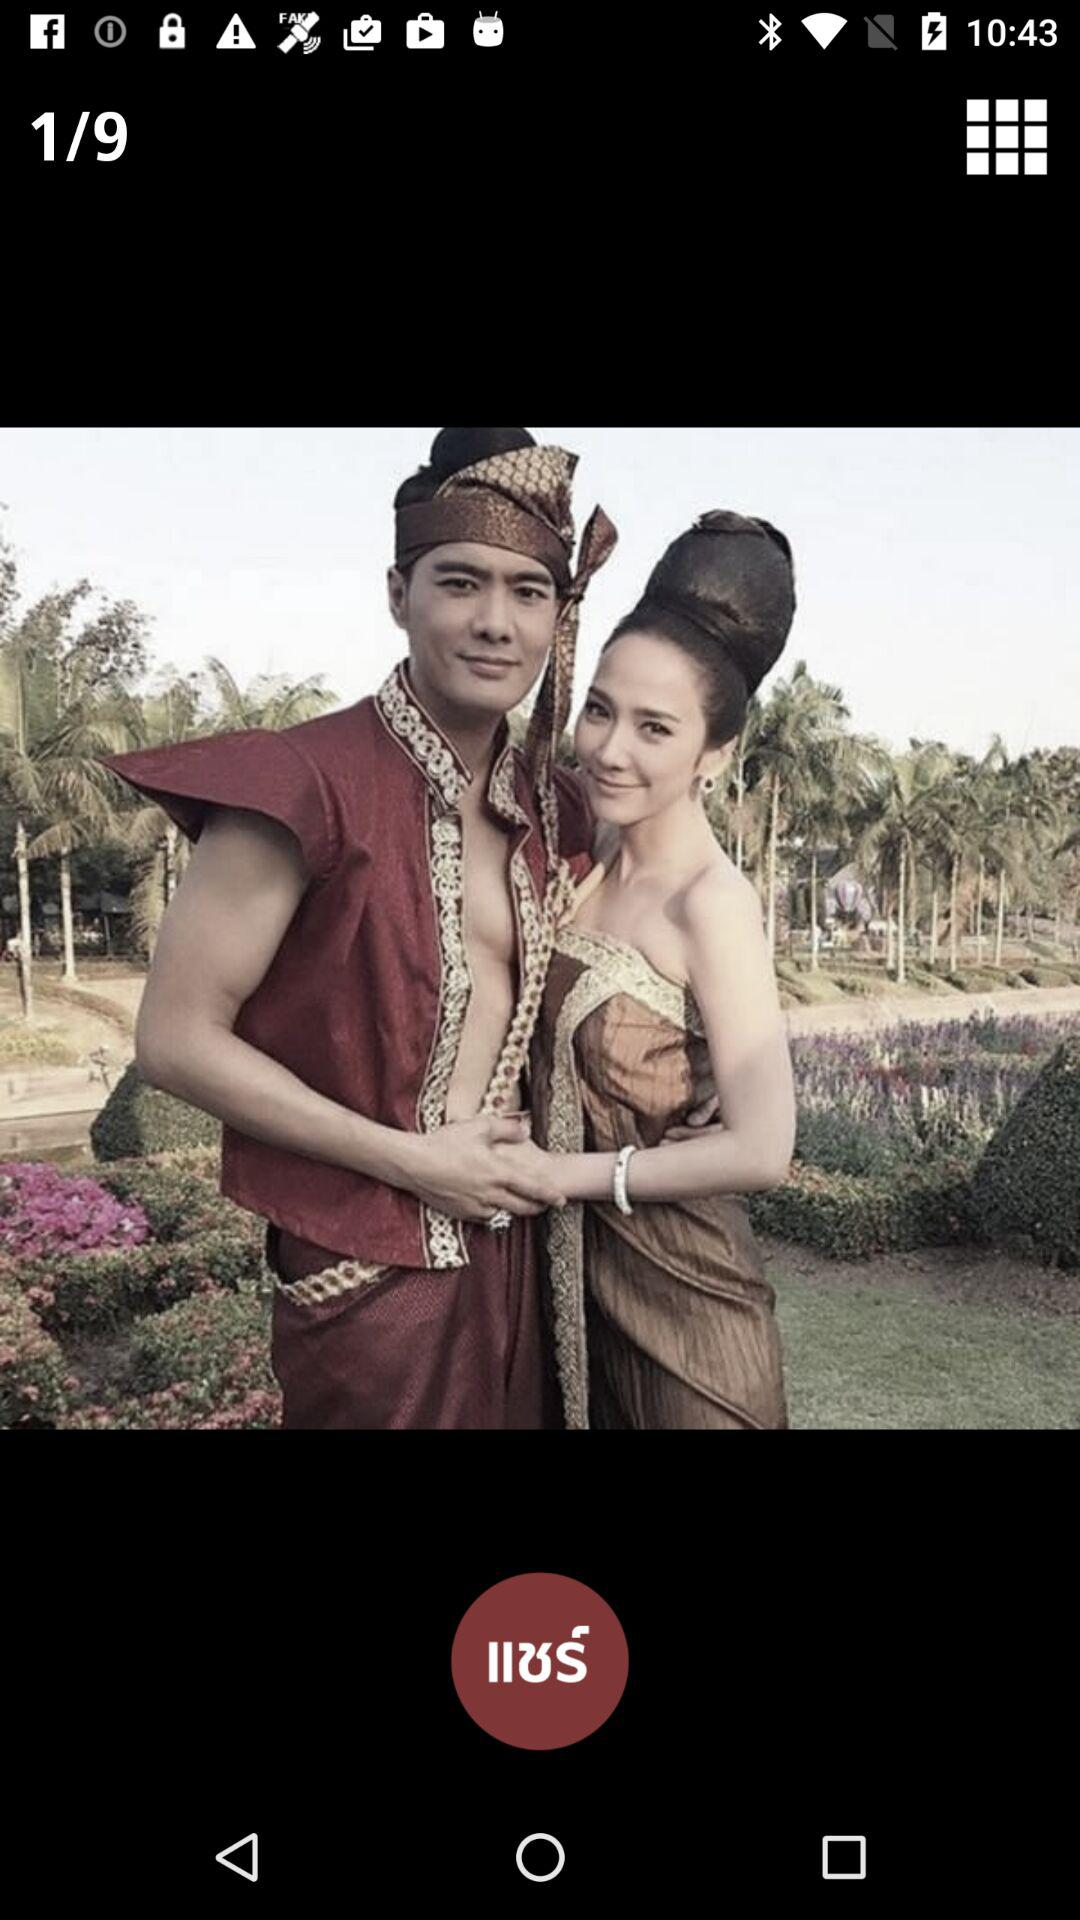Who took this photo?
When the provided information is insufficient, respond with <no answer>. <no answer> 